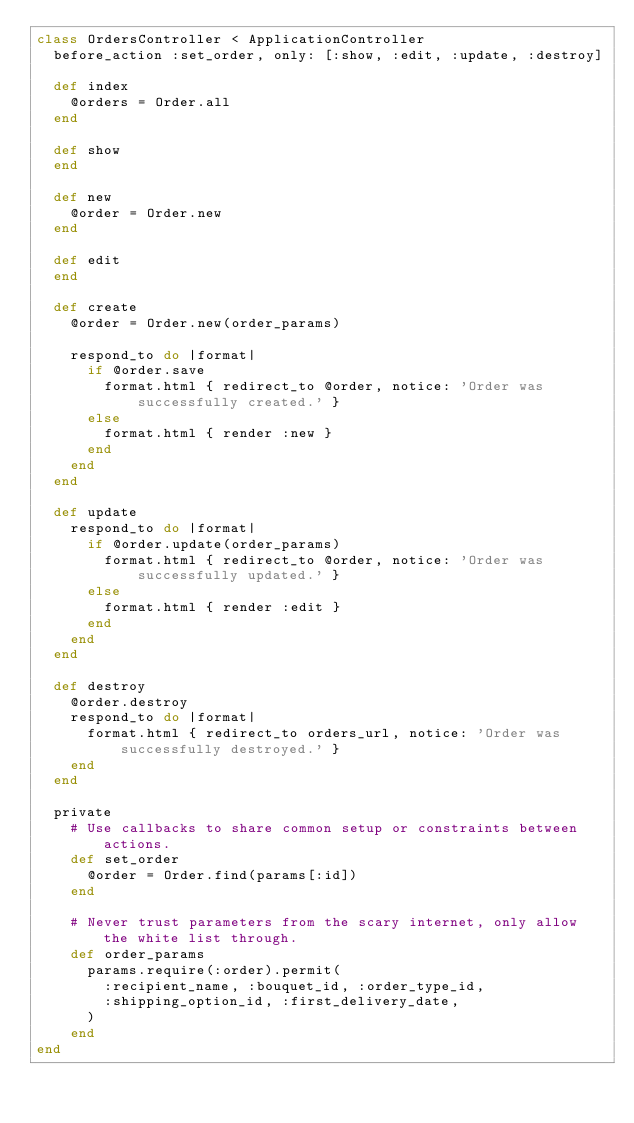Convert code to text. <code><loc_0><loc_0><loc_500><loc_500><_Ruby_>class OrdersController < ApplicationController
  before_action :set_order, only: [:show, :edit, :update, :destroy]

  def index
    @orders = Order.all
  end

  def show
  end

  def new
    @order = Order.new
  end

  def edit
  end

  def create
    @order = Order.new(order_params)

    respond_to do |format|
      if @order.save
        format.html { redirect_to @order, notice: 'Order was successfully created.' }
      else
        format.html { render :new }
      end
    end
  end

  def update
    respond_to do |format|
      if @order.update(order_params)
        format.html { redirect_to @order, notice: 'Order was successfully updated.' }
      else
        format.html { render :edit }
      end
    end
  end

  def destroy
    @order.destroy
    respond_to do |format|
      format.html { redirect_to orders_url, notice: 'Order was successfully destroyed.' }
    end
  end

  private
    # Use callbacks to share common setup or constraints between actions.
    def set_order
      @order = Order.find(params[:id])
    end

    # Never trust parameters from the scary internet, only allow the white list through.
    def order_params
      params.require(:order).permit(
        :recipient_name, :bouquet_id, :order_type_id,
        :shipping_option_id, :first_delivery_date,
      )
    end
end
</code> 